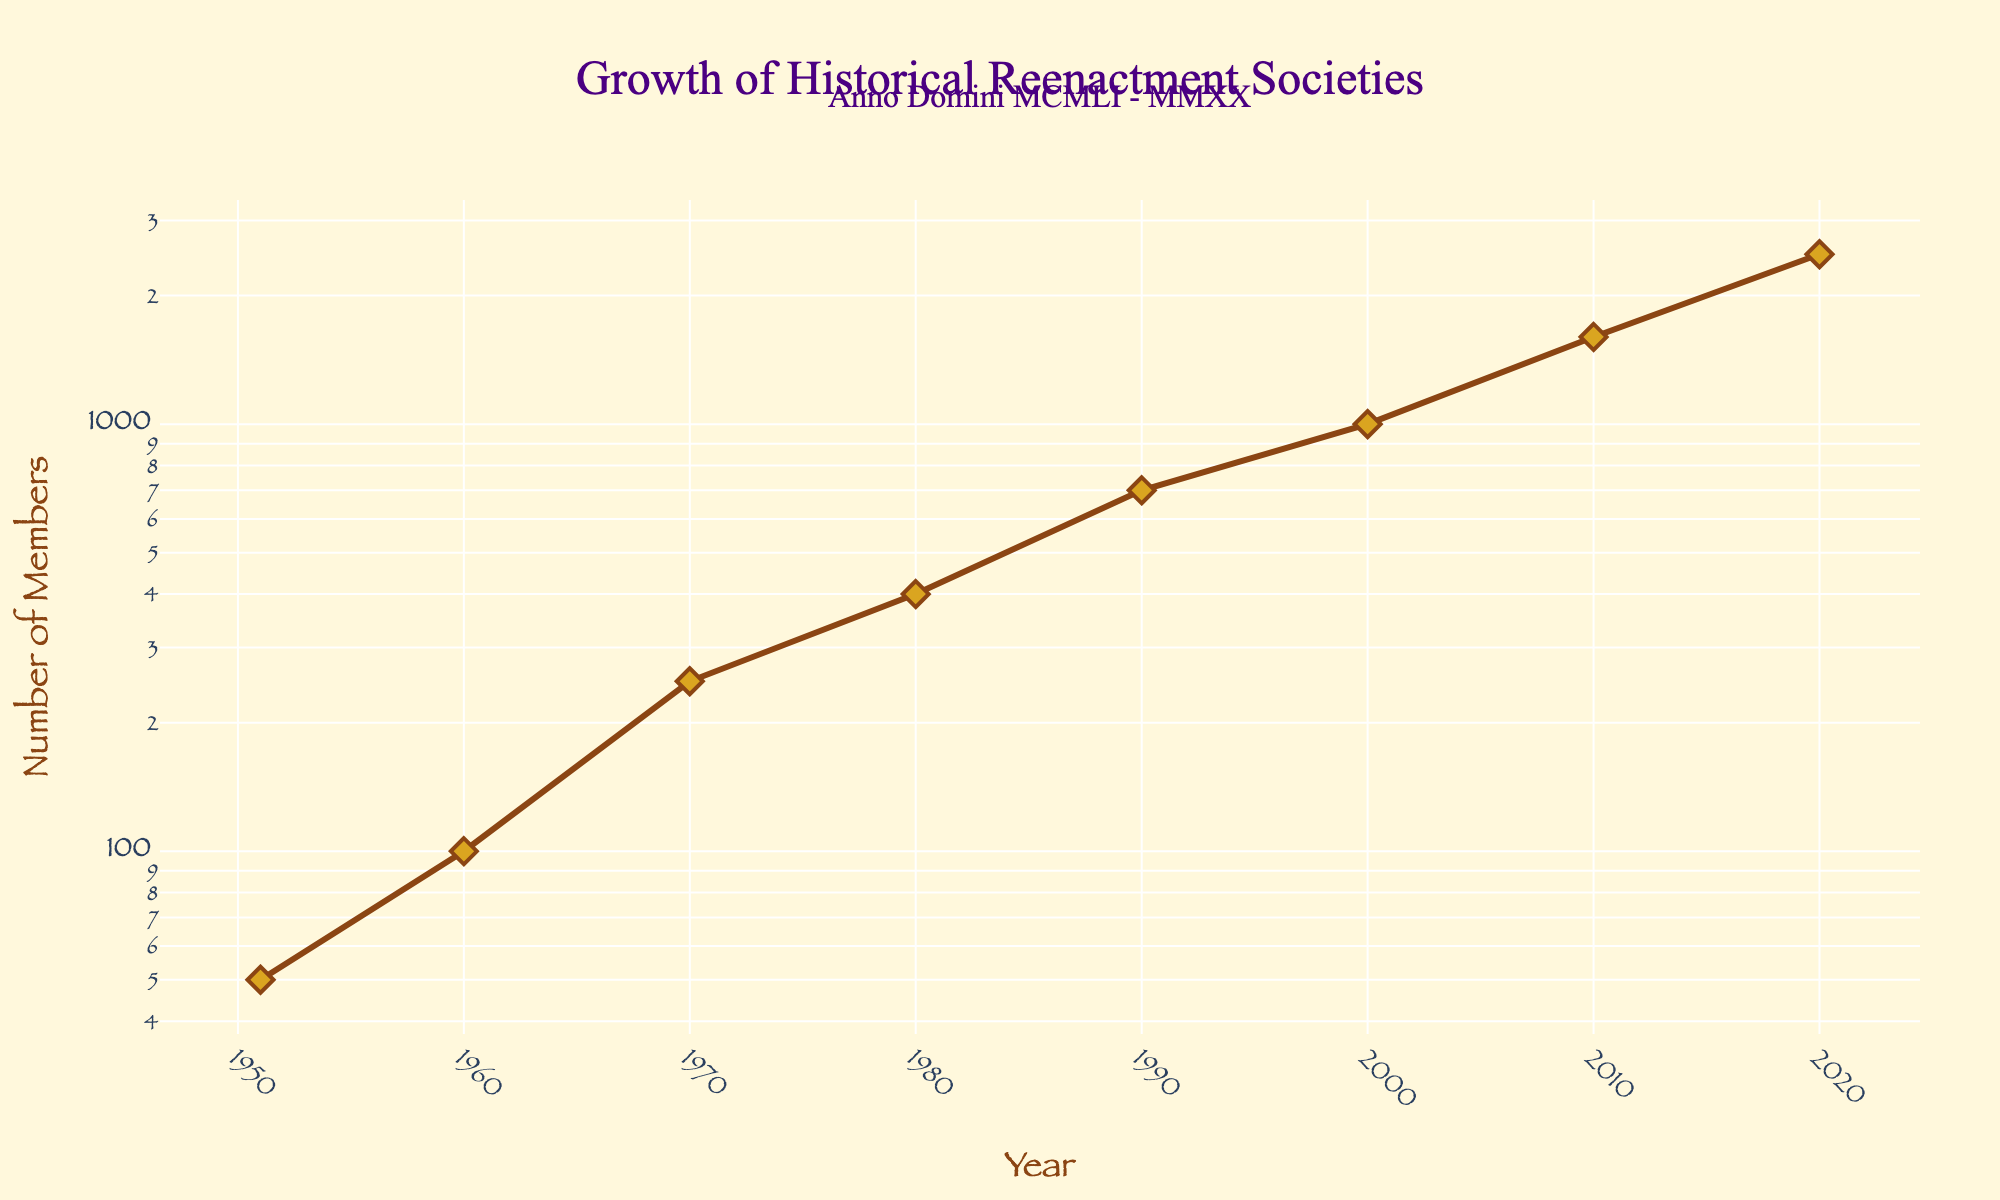What is the title of the plot? The title of the plot is displayed at the top and is usually styled with larger and more decorative fonts. In this figure, the title is emphasized using 'Old English Text MT' font and colored in '#4B0082'.
Answer: Growth of Historical Reenactment Societies What is the color of the plot’s background? The background color is a pale shade that complements the plot's aesthetic. This color is consistent across both the plot area and the paper background.
Answer: #FFF8DC How many data points are shown in the plot? By counting the markers on the line plot, you can see the total number of data points. Each marker represents a historical reenactment society at a specific year.
Answer: 8 Between which years did the number of members for historical reenactment societies see the largest increase? To determine this, look at the steepest section of the line on the log-scale plot. The largest increase is where the slope is most significant.
Answer: 2010 to 2020 Which society had 700 members, and in what year? Hovering over or interpreting the markers, especially around moderate y-axis values, can reveal specific society names and membership numbers.
Answer: Empire of Chivalry and Steel, 1990 What is the year range displayed on the x-axis? The x-axis, usually spanning the entire width of the plot with tick marks and labels, provides this information. Here, it shows the range from the first to the last year in the dataset.
Answer: 1951 to 2020 Compare the growth rate of memberships from the 1950s to 2000s with the growth rate from 2000s to 2020s. Which period had a steeper growth rate? On a log-scale plot, the steepness of the line indicates the growth rate. By visually comparing these periods on the plot, observe that the line's slope is steeper between the 2000s and 2020s.
Answer: 2000s to 2020s If the trend continues, predict the number of members by 2030. Based on the plot's current trajectory from 2010 to 2020, project the line's slope further. Since the line's steepness indicates rapid growth, estimate a considerable increase. Interpolating, it could be anticipated to be around 4000-5000 members.
Answer: 4000-5000 members Which society appears at the midpoint of the dataset in terms of years, and how many members did it have? Identify the midpoint year between 1951 and 2020, which is around 1985. Then, find the society closest to this year on the plot.
Answer: Adrian Empire, 400 members How many societies had less than 500 members? By examining the log-scale y-axis, identify the societies with values below 500. Count these societies based on the markers on the plot.
Answer: 3 societies (Society for Creative Anachronism, Regia Anglorum, Markland Medieval Mercenary Militia) 